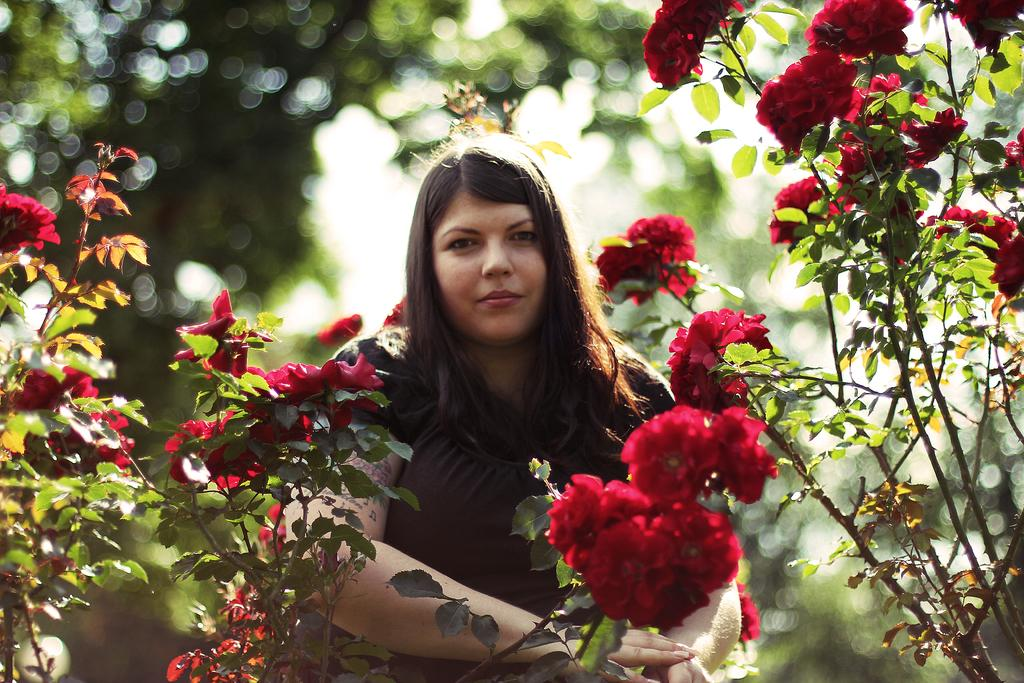Who or what is the main subject in the image? There is a person in the image. What type of plants can be seen in the image? There are plants with flowers in the image. Can you describe the background of the image? The background of the image is blurred. What type of fruit can be seen growing on the person's veins in the image? There is no fruit or veins visible on the person in the image. 